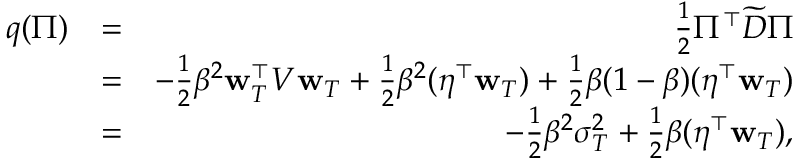Convert formula to latex. <formula><loc_0><loc_0><loc_500><loc_500>\begin{array} { r l r } { q ( \Pi ) } & { = } & { \frac { 1 } { 2 } \Pi ^ { \top } \widetilde { D } \Pi } \\ & { = } & { - \frac { 1 } { 2 } \beta ^ { 2 } { w } _ { T } ^ { \top } V { w } _ { T } + \frac { 1 } { 2 } \beta ^ { 2 } ( \eta ^ { \top } { w } _ { T } ) + \frac { 1 } { 2 } \beta ( 1 - \beta ) ( \eta ^ { \top } { w } _ { T } ) } \\ & { = } & { - \frac { 1 } { 2 } \beta ^ { 2 } \sigma _ { T } ^ { 2 } + \frac { 1 } { 2 } \beta ( \eta ^ { \top } { w } _ { T } ) , } \end{array}</formula> 